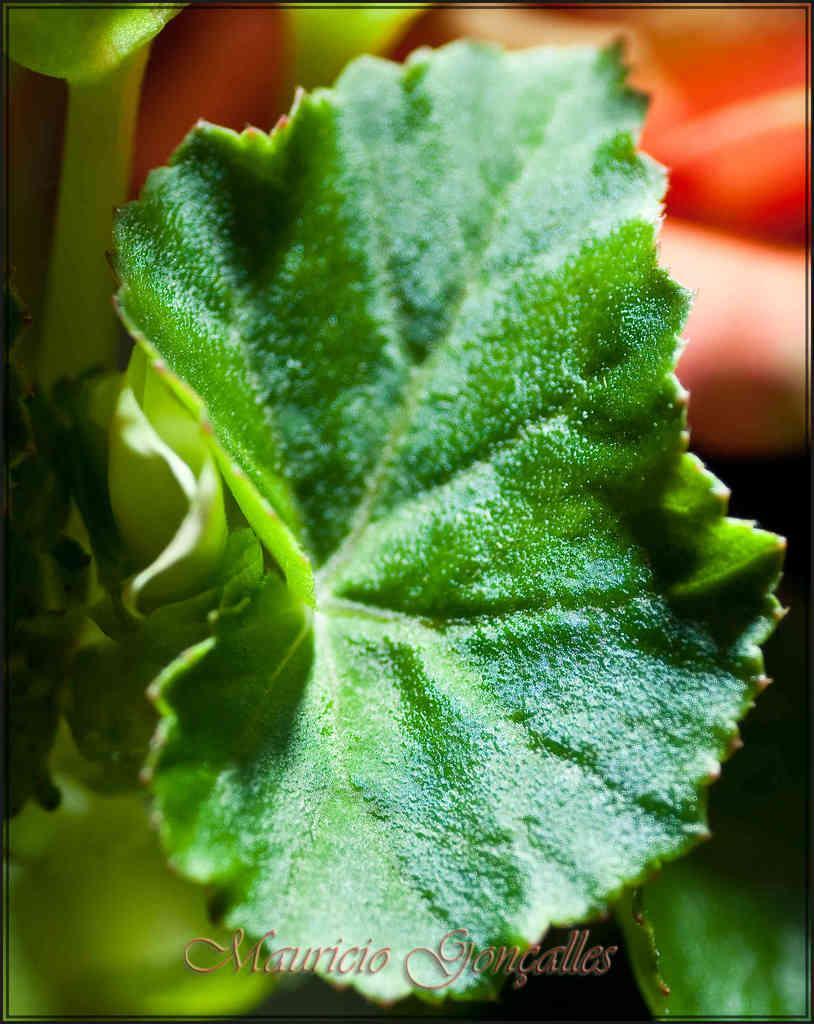Please provide a concise description of this image. In the image we can see there is a leaf and behind there are other items. Background of the image is blurred. 